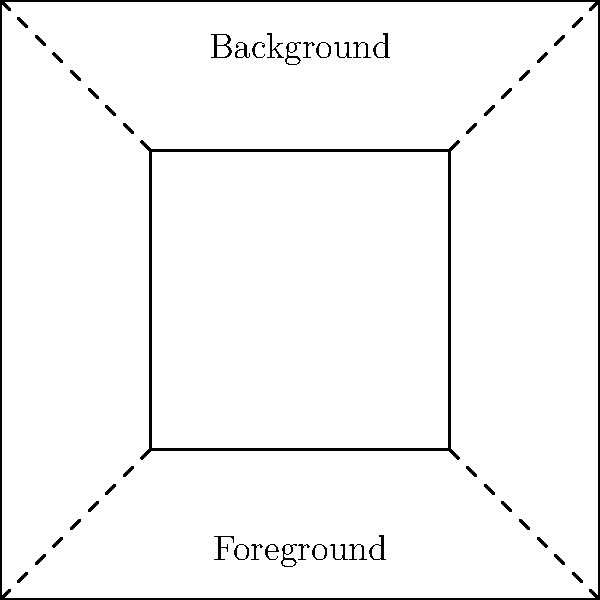In mural design, which perspective technique is illustrated by the diagram above, where objects appear smaller and converge towards a vanishing point as they recede into the distance? To understand the perspective technique illustrated in the diagram, let's break it down step-by-step:

1. The diagram shows two rectangles: a larger one representing the background and a smaller one representing the foreground.

2. The dashed lines connecting the corners of these rectangles are converging towards a point beyond the frame. This point is known as the vanishing point.

3. The foreground rectangle appears larger than the background rectangle, despite representing the same shape. This illustrates the principle that objects appear smaller as they move further away from the viewer.

4. The converging lines and the size difference between foreground and background elements are key characteristics of linear perspective.

5. In mural design, this technique is used to create the illusion of depth on a flat surface, making the artwork appear three-dimensional.

6. This specific type of linear perspective, where parallel lines converge to a single point, is called one-point perspective.

Therefore, the perspective technique illustrated in the diagram is one-point linear perspective, a fundamental method for creating depth in murals and other large-scale artworks.
Answer: One-point linear perspective 